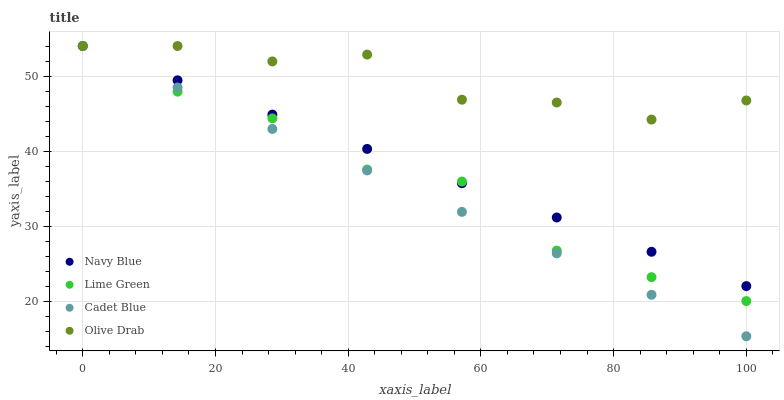Does Cadet Blue have the minimum area under the curve?
Answer yes or no. Yes. Does Olive Drab have the maximum area under the curve?
Answer yes or no. Yes. Does Lime Green have the minimum area under the curve?
Answer yes or no. No. Does Lime Green have the maximum area under the curve?
Answer yes or no. No. Is Cadet Blue the smoothest?
Answer yes or no. Yes. Is Lime Green the roughest?
Answer yes or no. Yes. Is Lime Green the smoothest?
Answer yes or no. No. Is Cadet Blue the roughest?
Answer yes or no. No. Does Cadet Blue have the lowest value?
Answer yes or no. Yes. Does Lime Green have the lowest value?
Answer yes or no. No. Does Olive Drab have the highest value?
Answer yes or no. Yes. Does Lime Green intersect Cadet Blue?
Answer yes or no. Yes. Is Lime Green less than Cadet Blue?
Answer yes or no. No. Is Lime Green greater than Cadet Blue?
Answer yes or no. No. 